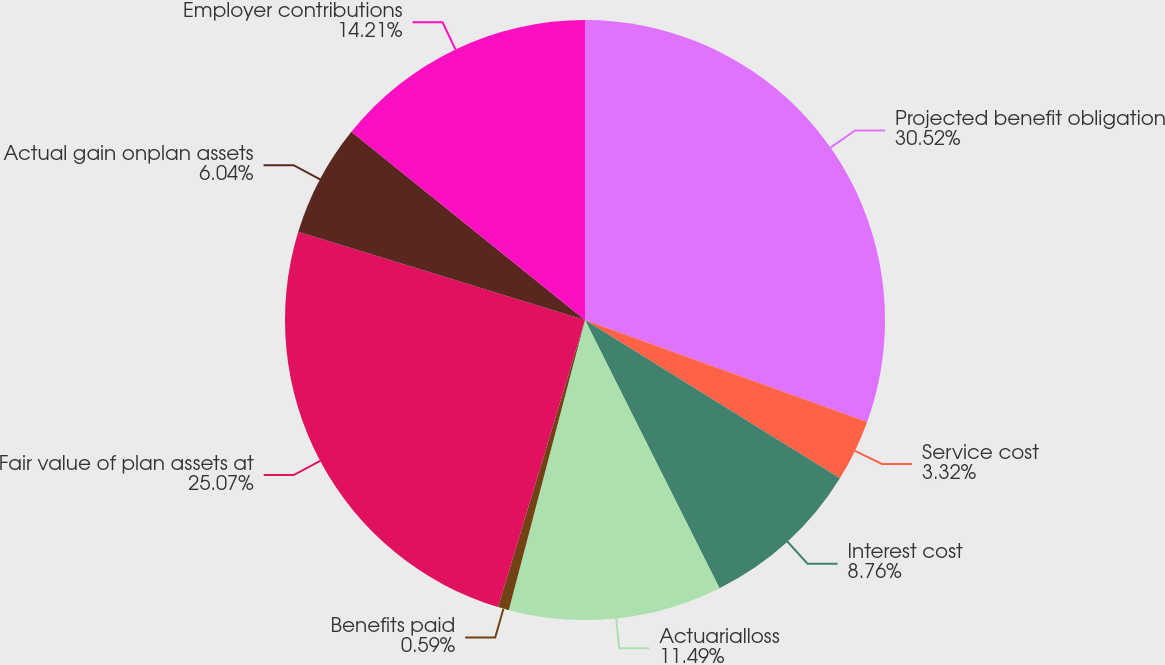Convert chart. <chart><loc_0><loc_0><loc_500><loc_500><pie_chart><fcel>Projected benefit obligation<fcel>Service cost<fcel>Interest cost<fcel>Actuarialloss<fcel>Benefits paid<fcel>Fair value of plan assets at<fcel>Actual gain onplan assets<fcel>Employer contributions<nl><fcel>30.52%<fcel>3.32%<fcel>8.76%<fcel>11.49%<fcel>0.59%<fcel>25.07%<fcel>6.04%<fcel>14.21%<nl></chart> 